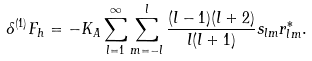Convert formula to latex. <formula><loc_0><loc_0><loc_500><loc_500>\delta ^ { ( 1 ) } F _ { h } = - K _ { A } \sum _ { l = 1 } ^ { \infty } \sum _ { m = - l } ^ { l } \frac { ( l - 1 ) ( l + 2 ) } { l ( l + 1 ) } s _ { l m } r _ { l m } ^ { * } .</formula> 